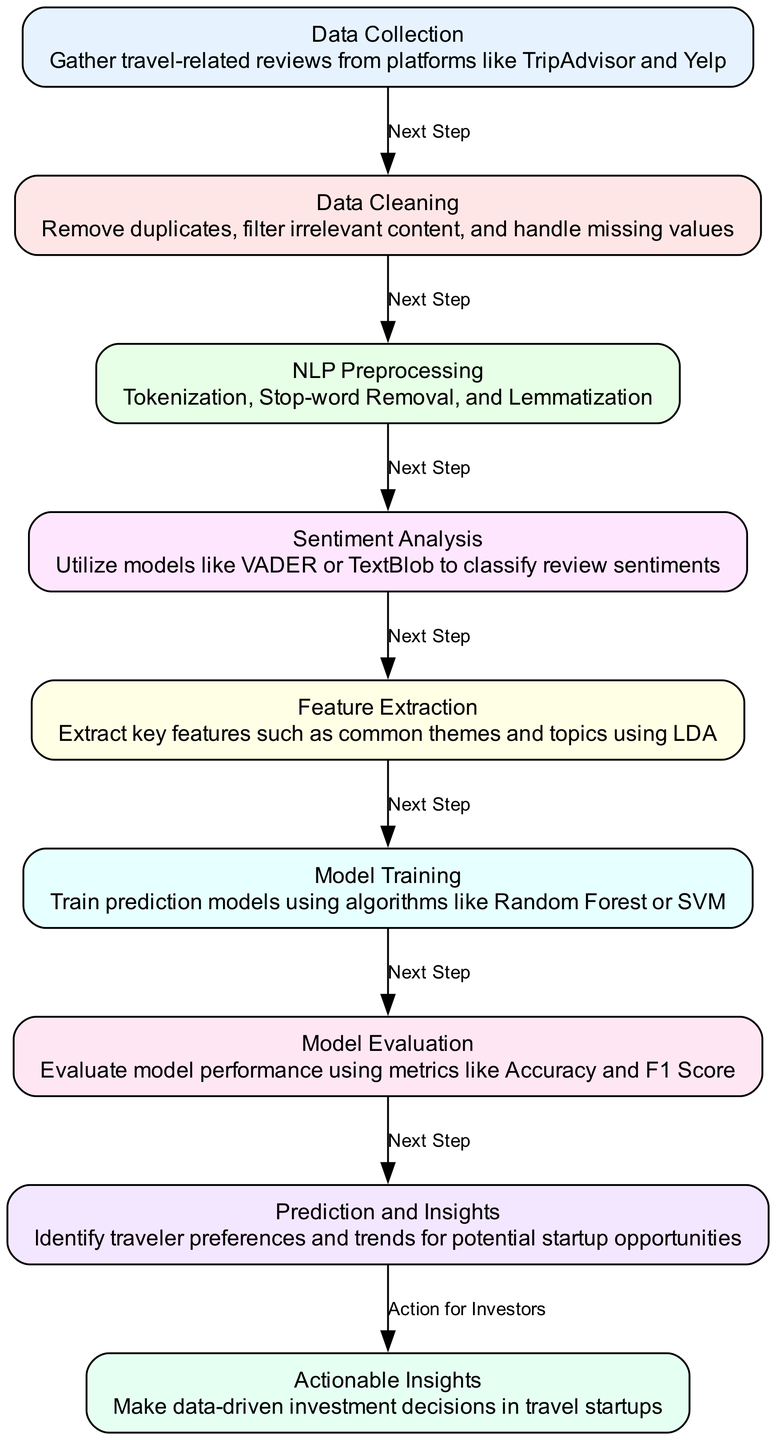What is the first step in the diagram? The first step or node in the diagram is "Data Collection", which is identified as the initial process to gather travel-related reviews.
Answer: Data Collection How many nodes are there in the diagram? Counting all nodes listed in the diagram, there are a total of 9 nodes representing different steps in the machine learning process.
Answer: 9 What type of analysis is performed after NLP Preprocessing? After the NLP Preprocessing step, the next analysis conducted is "Sentiment Analysis", which focuses on classifying review sentiments.
Answer: Sentiment Analysis What is the last step before actionable insights are generated? The last step before generating actionable insights is "Prediction and Insights", where traveler preferences and trends are identified for startups.
Answer: Prediction and Insights Which model evaluation metric is mentioned in the diagram? The diagram mentions evaluating the model performance using metrics such as Accuracy and F1 Score, which are common metrics for assessing machine learning models.
Answer: Accuracy and F1 Score What follows "Feature Extraction" in the diagram? The step that follows "Feature Extraction" is "Model Training", where prediction models are developed using algorithms.
Answer: Model Training How many edges are there in the diagram? By counting the connections between the nodes, there are 8 edges in total, showing the flow between different steps of the process.
Answer: 8 What type of models are used in the "Model Training" step? The "Model Training" step employs algorithms like Random Forest or SVM to train the prediction models.
Answer: Random Forest or SVM What is the overall goal described in the diagram? The overall goal represented in the diagram is to produce "Actionable Insights" that can inform data-driven investment decisions in travel startups.
Answer: Actionable Insights 